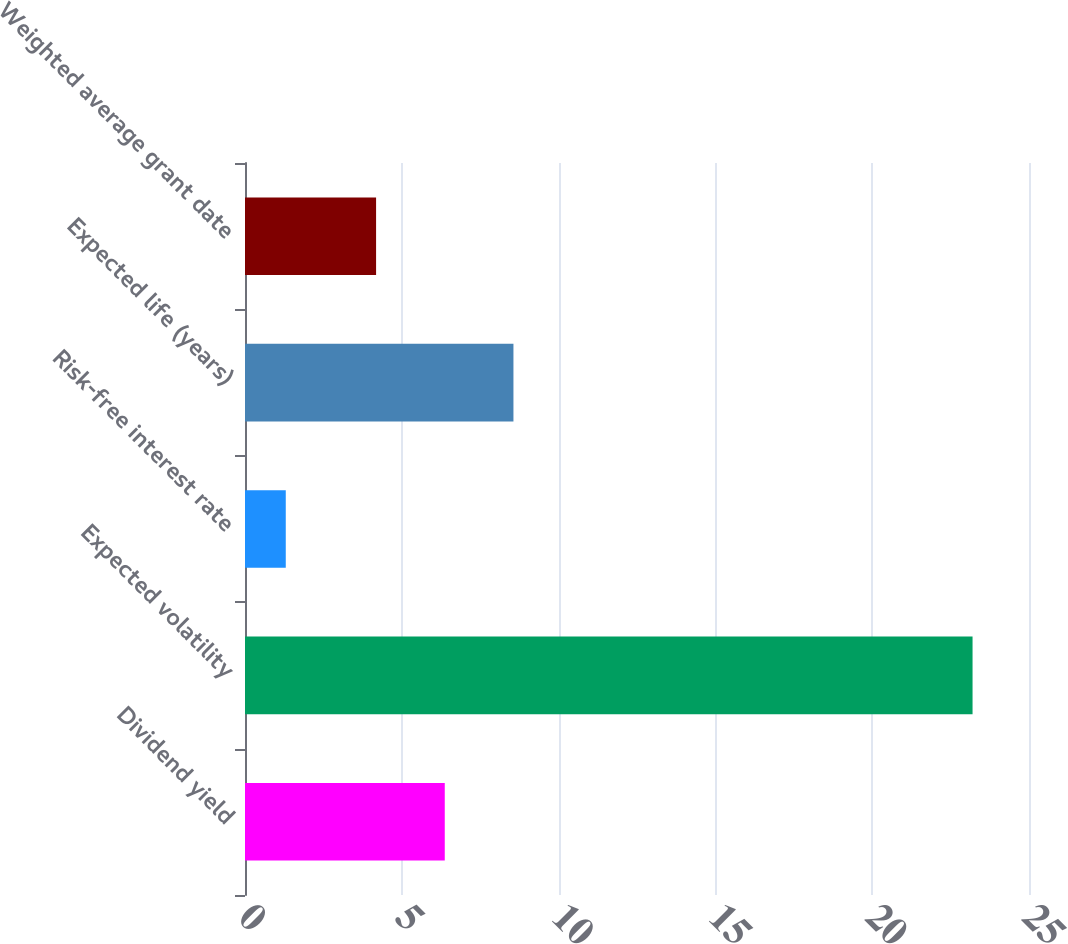Convert chart to OTSL. <chart><loc_0><loc_0><loc_500><loc_500><bar_chart><fcel>Dividend yield<fcel>Expected volatility<fcel>Risk-free interest rate<fcel>Expected life (years)<fcel>Weighted average grant date<nl><fcel>6.37<fcel>23.2<fcel>1.3<fcel>8.56<fcel>4.18<nl></chart> 